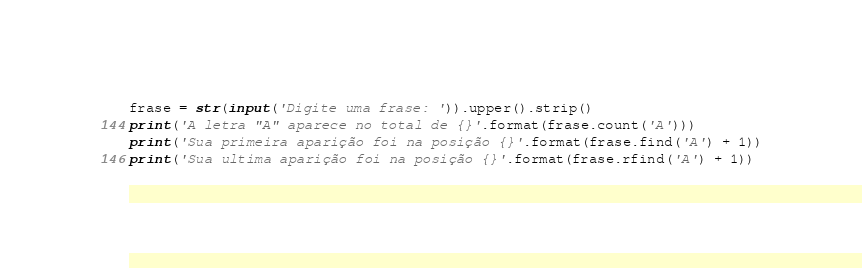<code> <loc_0><loc_0><loc_500><loc_500><_Python_>frase = str(input('Digite uma frase: ')).upper().strip()
print('A letra "A" aparece no total de {}'.format(frase.count('A')))
print('Sua primeira aparição foi na posição {}'.format(frase.find('A') + 1))
print('Sua ultima aparição foi na posição {}'.format(frase.rfind('A') + 1))</code> 